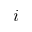<formula> <loc_0><loc_0><loc_500><loc_500>i</formula> 